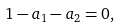<formula> <loc_0><loc_0><loc_500><loc_500>1 - a _ { 1 } - a _ { 2 } = 0 ,</formula> 